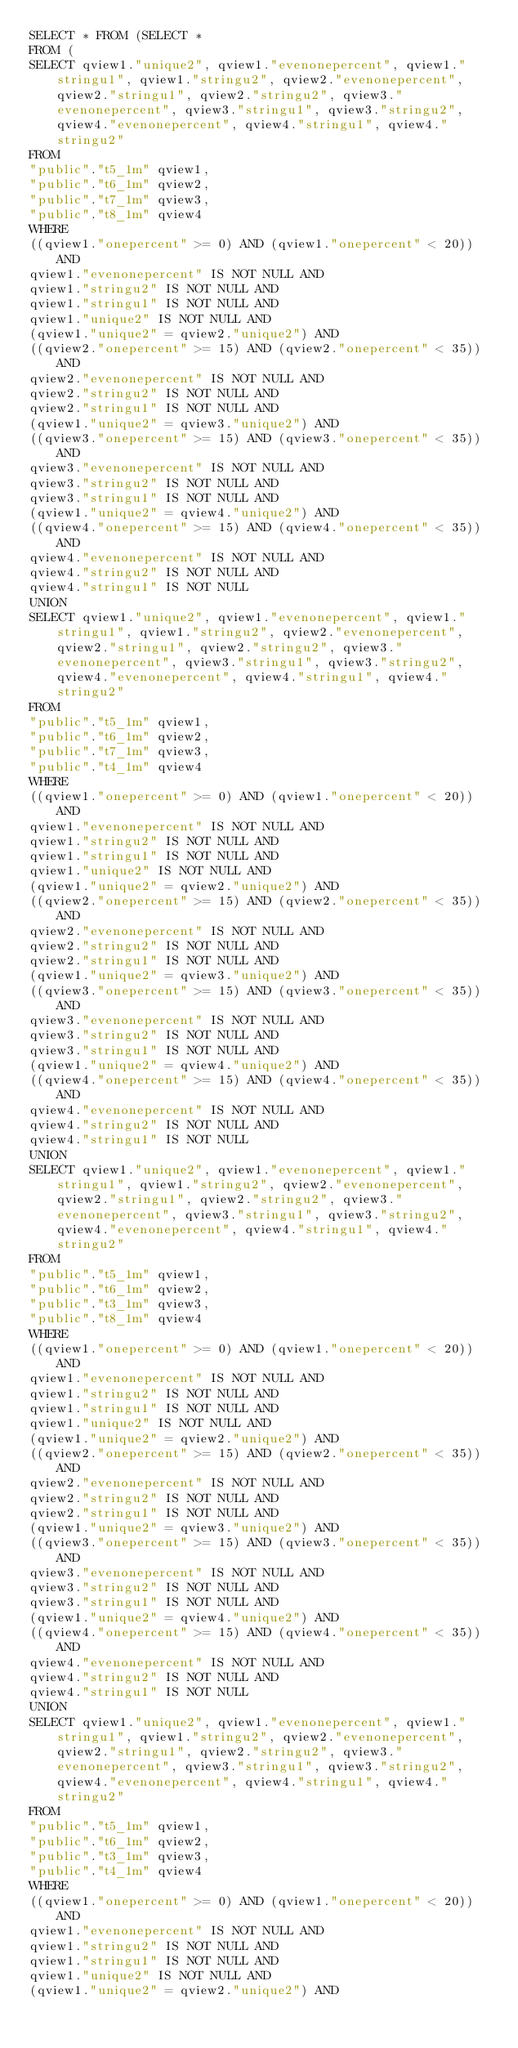<code> <loc_0><loc_0><loc_500><loc_500><_SQL_>SELECT * FROM (SELECT *
FROM (
SELECT qview1."unique2", qview1."evenonepercent", qview1."stringu1", qview1."stringu2", qview2."evenonepercent", qview2."stringu1", qview2."stringu2", qview3."evenonepercent", qview3."stringu1", qview3."stringu2", qview4."evenonepercent", qview4."stringu1", qview4."stringu2"
FROM
"public"."t5_1m" qview1,
"public"."t6_1m" qview2,
"public"."t7_1m" qview3,
"public"."t8_1m" qview4
WHERE
((qview1."onepercent" >= 0) AND (qview1."onepercent" < 20)) AND
qview1."evenonepercent" IS NOT NULL AND
qview1."stringu2" IS NOT NULL AND
qview1."stringu1" IS NOT NULL AND
qview1."unique2" IS NOT NULL AND
(qview1."unique2" = qview2."unique2") AND
((qview2."onepercent" >= 15) AND (qview2."onepercent" < 35)) AND
qview2."evenonepercent" IS NOT NULL AND
qview2."stringu2" IS NOT NULL AND
qview2."stringu1" IS NOT NULL AND
(qview1."unique2" = qview3."unique2") AND
((qview3."onepercent" >= 15) AND (qview3."onepercent" < 35)) AND
qview3."evenonepercent" IS NOT NULL AND
qview3."stringu2" IS NOT NULL AND
qview3."stringu1" IS NOT NULL AND
(qview1."unique2" = qview4."unique2") AND
((qview4."onepercent" >= 15) AND (qview4."onepercent" < 35)) AND
qview4."evenonepercent" IS NOT NULL AND
qview4."stringu2" IS NOT NULL AND
qview4."stringu1" IS NOT NULL
UNION
SELECT qview1."unique2", qview1."evenonepercent", qview1."stringu1", qview1."stringu2", qview2."evenonepercent", qview2."stringu1", qview2."stringu2", qview3."evenonepercent", qview3."stringu1", qview3."stringu2", qview4."evenonepercent", qview4."stringu1", qview4."stringu2"
FROM
"public"."t5_1m" qview1,
"public"."t6_1m" qview2,
"public"."t7_1m" qview3,
"public"."t4_1m" qview4
WHERE
((qview1."onepercent" >= 0) AND (qview1."onepercent" < 20)) AND
qview1."evenonepercent" IS NOT NULL AND
qview1."stringu2" IS NOT NULL AND
qview1."stringu1" IS NOT NULL AND
qview1."unique2" IS NOT NULL AND
(qview1."unique2" = qview2."unique2") AND
((qview2."onepercent" >= 15) AND (qview2."onepercent" < 35)) AND
qview2."evenonepercent" IS NOT NULL AND
qview2."stringu2" IS NOT NULL AND
qview2."stringu1" IS NOT NULL AND
(qview1."unique2" = qview3."unique2") AND
((qview3."onepercent" >= 15) AND (qview3."onepercent" < 35)) AND
qview3."evenonepercent" IS NOT NULL AND
qview3."stringu2" IS NOT NULL AND
qview3."stringu1" IS NOT NULL AND
(qview1."unique2" = qview4."unique2") AND
((qview4."onepercent" >= 15) AND (qview4."onepercent" < 35)) AND
qview4."evenonepercent" IS NOT NULL AND
qview4."stringu2" IS NOT NULL AND
qview4."stringu1" IS NOT NULL
UNION
SELECT qview1."unique2", qview1."evenonepercent", qview1."stringu1", qview1."stringu2", qview2."evenonepercent", qview2."stringu1", qview2."stringu2", qview3."evenonepercent", qview3."stringu1", qview3."stringu2", qview4."evenonepercent", qview4."stringu1", qview4."stringu2"
FROM
"public"."t5_1m" qview1,
"public"."t6_1m" qview2,
"public"."t3_1m" qview3,
"public"."t8_1m" qview4
WHERE
((qview1."onepercent" >= 0) AND (qview1."onepercent" < 20)) AND
qview1."evenonepercent" IS NOT NULL AND
qview1."stringu2" IS NOT NULL AND
qview1."stringu1" IS NOT NULL AND
qview1."unique2" IS NOT NULL AND
(qview1."unique2" = qview2."unique2") AND
((qview2."onepercent" >= 15) AND (qview2."onepercent" < 35)) AND
qview2."evenonepercent" IS NOT NULL AND
qview2."stringu2" IS NOT NULL AND
qview2."stringu1" IS NOT NULL AND
(qview1."unique2" = qview3."unique2") AND
((qview3."onepercent" >= 15) AND (qview3."onepercent" < 35)) AND
qview3."evenonepercent" IS NOT NULL AND
qview3."stringu2" IS NOT NULL AND
qview3."stringu1" IS NOT NULL AND
(qview1."unique2" = qview4."unique2") AND
((qview4."onepercent" >= 15) AND (qview4."onepercent" < 35)) AND
qview4."evenonepercent" IS NOT NULL AND
qview4."stringu2" IS NOT NULL AND
qview4."stringu1" IS NOT NULL
UNION
SELECT qview1."unique2", qview1."evenonepercent", qview1."stringu1", qview1."stringu2", qview2."evenonepercent", qview2."stringu1", qview2."stringu2", qview3."evenonepercent", qview3."stringu1", qview3."stringu2", qview4."evenonepercent", qview4."stringu1", qview4."stringu2"
FROM
"public"."t5_1m" qview1,
"public"."t6_1m" qview2,
"public"."t3_1m" qview3,
"public"."t4_1m" qview4
WHERE
((qview1."onepercent" >= 0) AND (qview1."onepercent" < 20)) AND
qview1."evenonepercent" IS NOT NULL AND
qview1."stringu2" IS NOT NULL AND
qview1."stringu1" IS NOT NULL AND
qview1."unique2" IS NOT NULL AND
(qview1."unique2" = qview2."unique2") AND</code> 